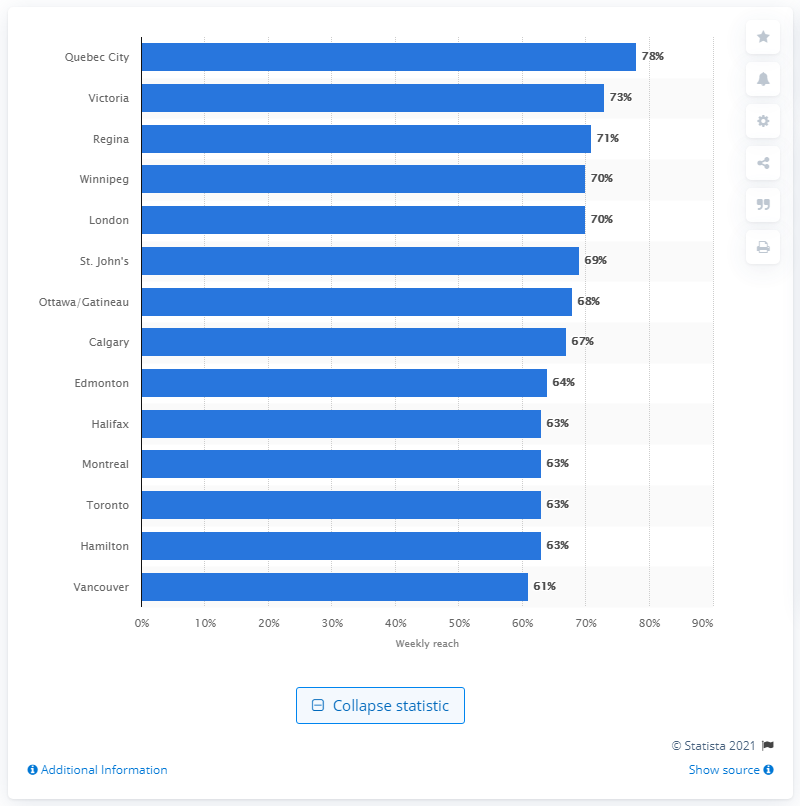Point out several critical features in this image. In the city of Calgary, daily newspapers were more popular than those in Winnipeg and Regina. 